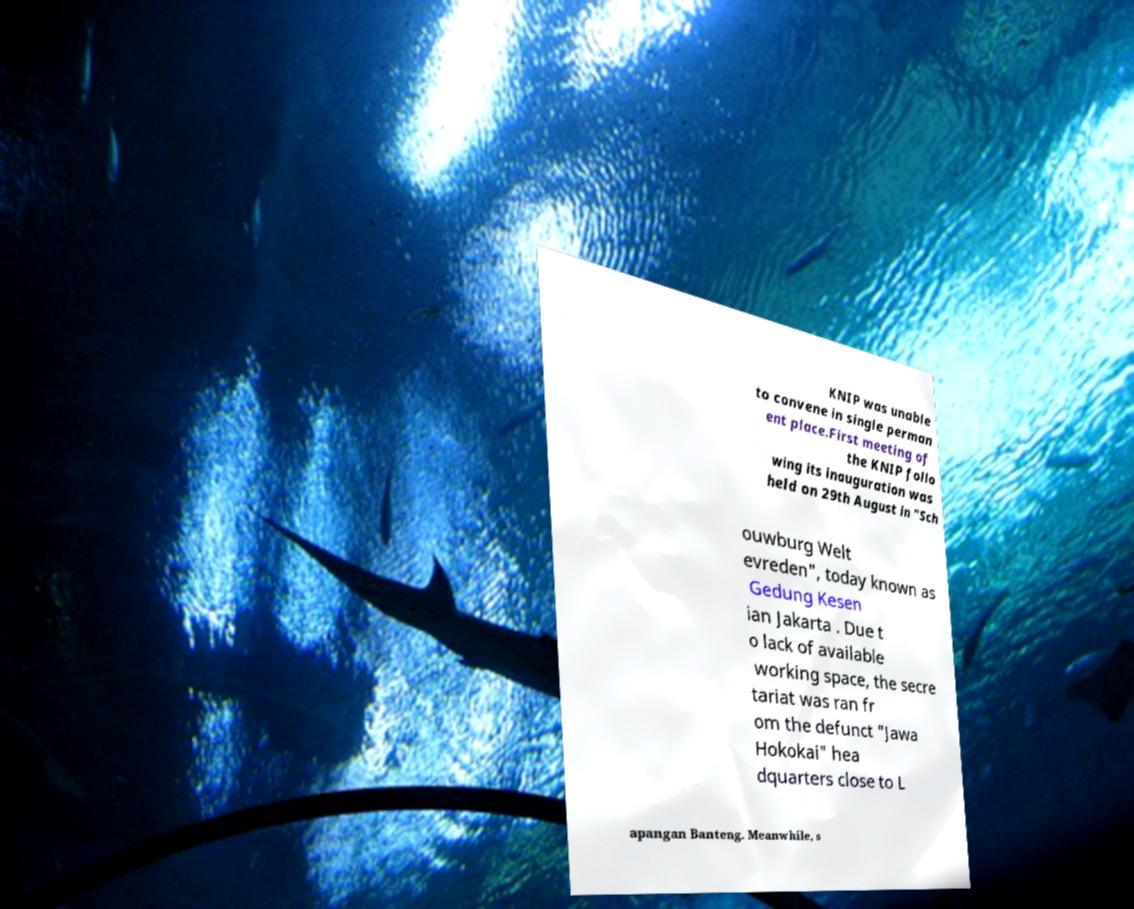I need the written content from this picture converted into text. Can you do that? KNIP was unable to convene in single perman ent place.First meeting of the KNIP follo wing its inauguration was held on 29th August in "Sch ouwburg Welt evreden", today known as Gedung Kesen ian Jakarta . Due t o lack of available working space, the secre tariat was ran fr om the defunct "Jawa Hokokai" hea dquarters close to L apangan Banteng. Meanwhile, s 